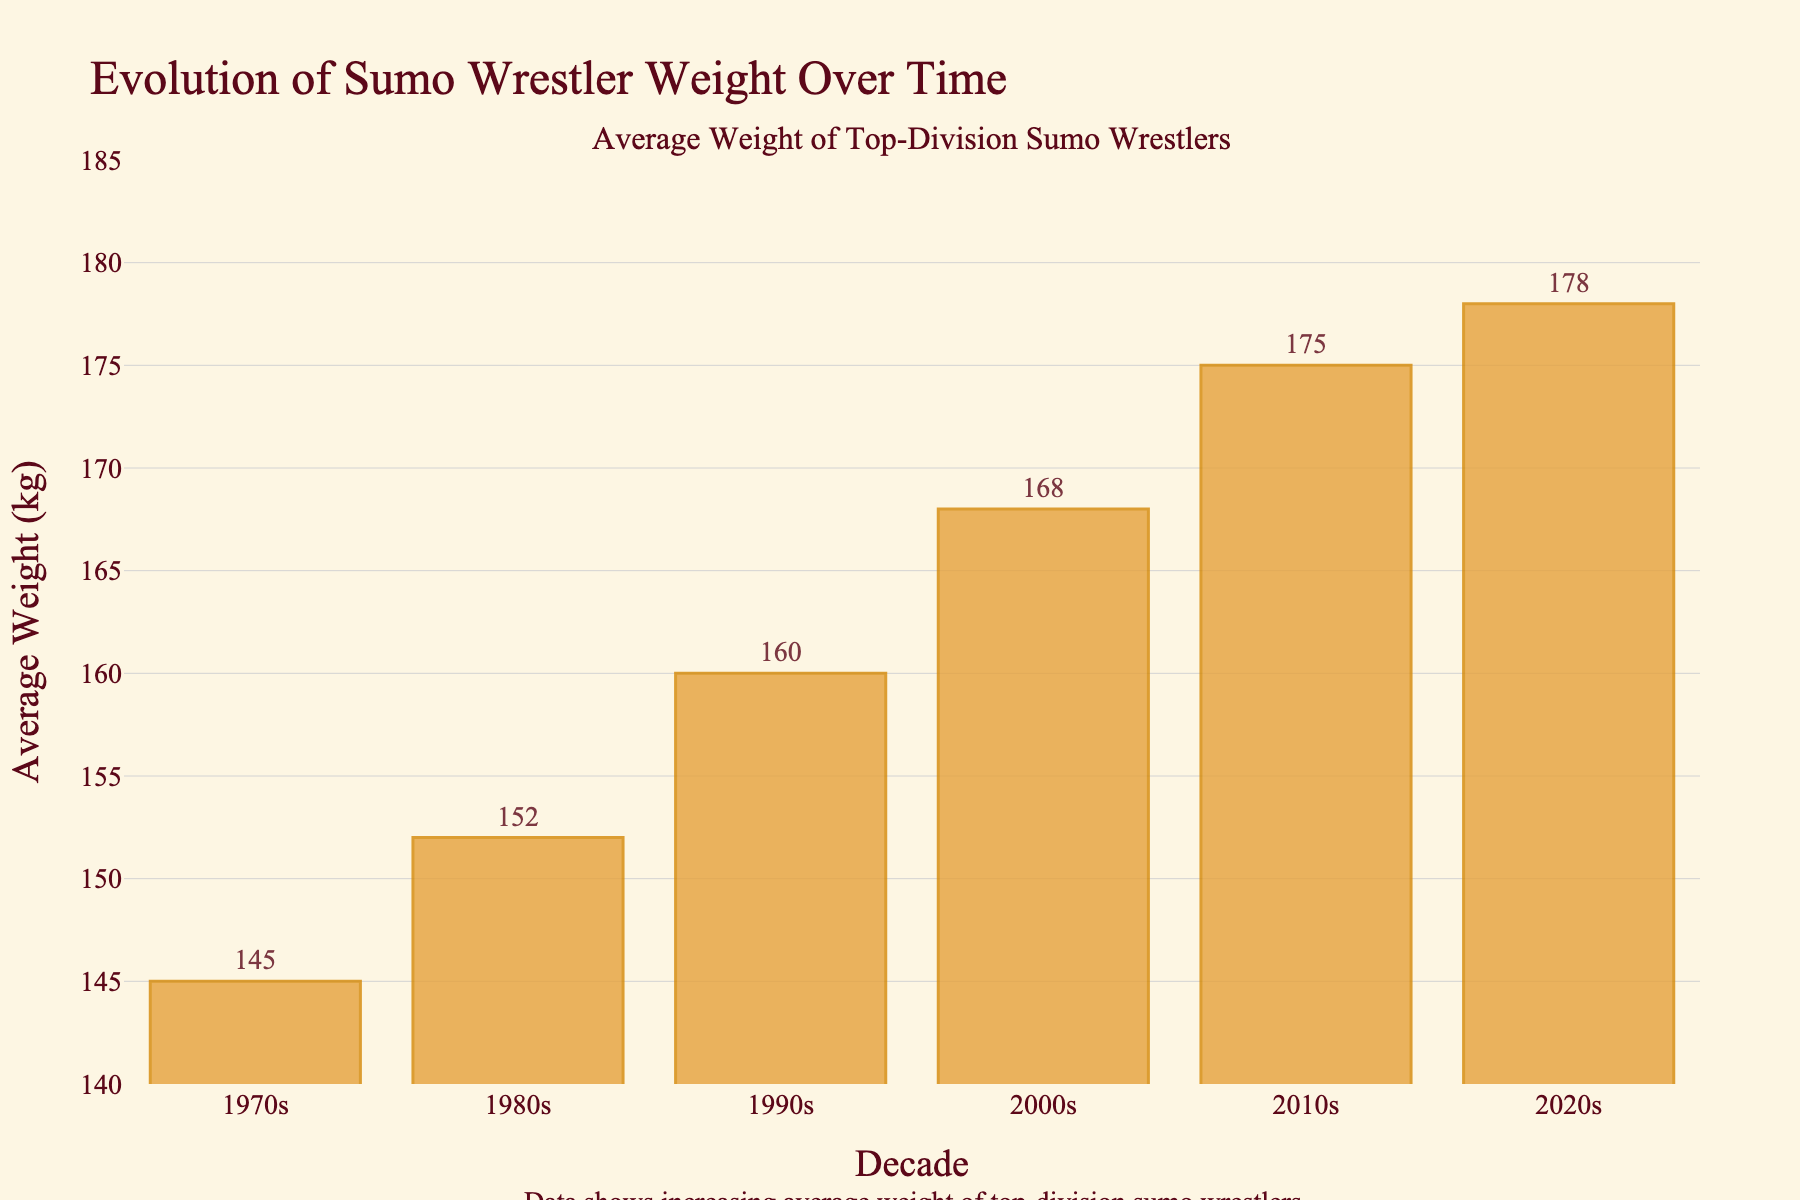What is the average weight of top-division sumo wrestlers in the 1990s? Look at the bar corresponding to the 1990s and read the height, which is labeled as 160 kg.
Answer: 160 kg Which decade saw the greatest increase in the average weight of sumo wrestlers compared to the previous decade? Compare the differences in heights of the bars across the decades. The increase from the 1980s (152 kg) to the 1990s (160 kg) is 8 kg. From the 1990s to the 2000s (168 kg) is also 8 kg. However, from the 2000s to the 2010s (175 kg) is 7 kg. Thus, the 1990s saw the greatest increase of 8 kg.
Answer: 1990s What is the total combined average weight of sumo wrestlers in the 1970s and the 2020s? Add the values of the average weights of the 1970s (145 kg) and the 2020s (178 kg).
Answer: 323 kg By how many kilograms did the average weight of top-division sumo wrestlers increase from the 1970s to the 2020s? Subtract the average weight of the 1970s (145 kg) from the average weight of the 2020s (178 kg).
Answer: 33 kg Which decade has the lowest average weight of sumo wrestlers? Identify the shortest bar; it's labeled as 1970s with 145 kg.
Answer: 1970s How does the average weight in the 2010s compare to the average weight in the 1980s? Compare the values of 2010s (175 kg) and 1980s (152 kg), and find the difference.
Answer: 23 kg higher What trend can be observed in the average weight of top-division sumo wrestlers over the decades? The heights of the bars increase consistently from the 1970s to the 2020s, indicating a rising trend in average weight.
Answer: Increasing trend How much higher is the average weight in the 2000s compared to the 1980s? Subtract the average weight of the 1980s (152 kg) from that of the 2000s (168 kg).
Answer: 16 kg Is the increase in average weight from the 2000s to the 2020s larger or smaller than the increase from the 1970s to the 1980s? Calculate the increase from the 2000s (168 kg) to the 2020s (178 kg), which is 10 kg. Then, calculate the increase from the 1970s (145 kg) to the 1980s (152 kg), which is 7 kg. Compare the two values.
Answer: Larger What is the range of the average weights during the observed decades? Subtract the lowest average weight (1970s: 145 kg) from the highest average weight (2020s: 178 kg).
Answer: 33 kg 